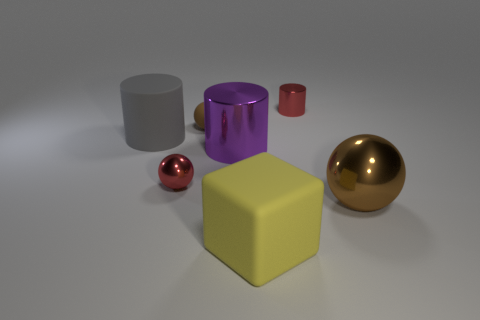Add 3 tiny red matte cylinders. How many objects exist? 10 Subtract all cylinders. How many objects are left? 4 Subtract all purple spheres. Subtract all big yellow rubber cubes. How many objects are left? 6 Add 6 rubber spheres. How many rubber spheres are left? 7 Add 7 tiny red cylinders. How many tiny red cylinders exist? 8 Subtract 0 green spheres. How many objects are left? 7 